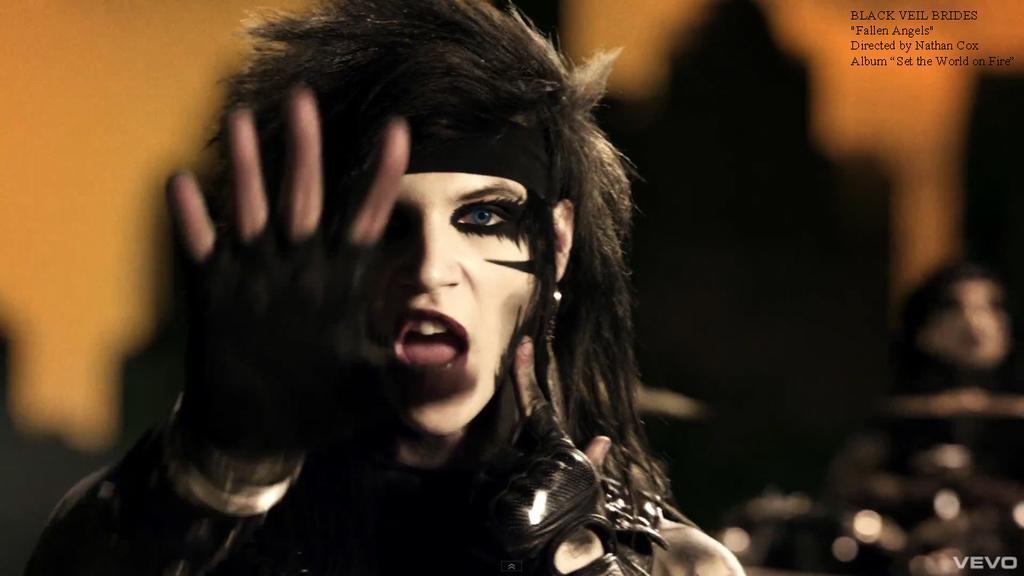Could you give a brief overview of what you see in this image? In this image I can see a person wearing black color dress and the person is also wearing black color cloves and I can see blurred background. 